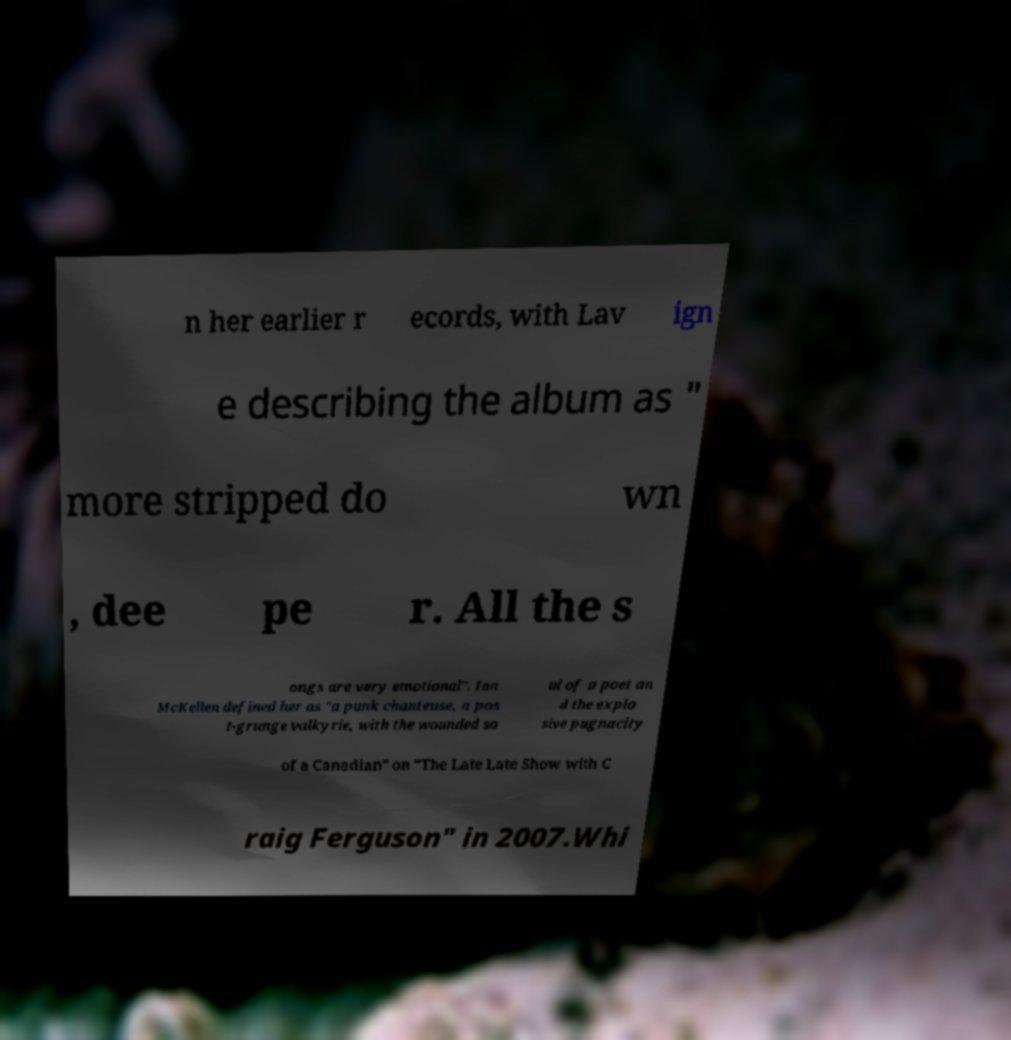Please identify and transcribe the text found in this image. n her earlier r ecords, with Lav ign e describing the album as " more stripped do wn , dee pe r. All the s ongs are very emotional". Ian McKellen defined her as "a punk chanteuse, a pos t-grunge valkyrie, with the wounded so ul of a poet an d the explo sive pugnacity of a Canadian" on "The Late Late Show with C raig Ferguson" in 2007.Whi 